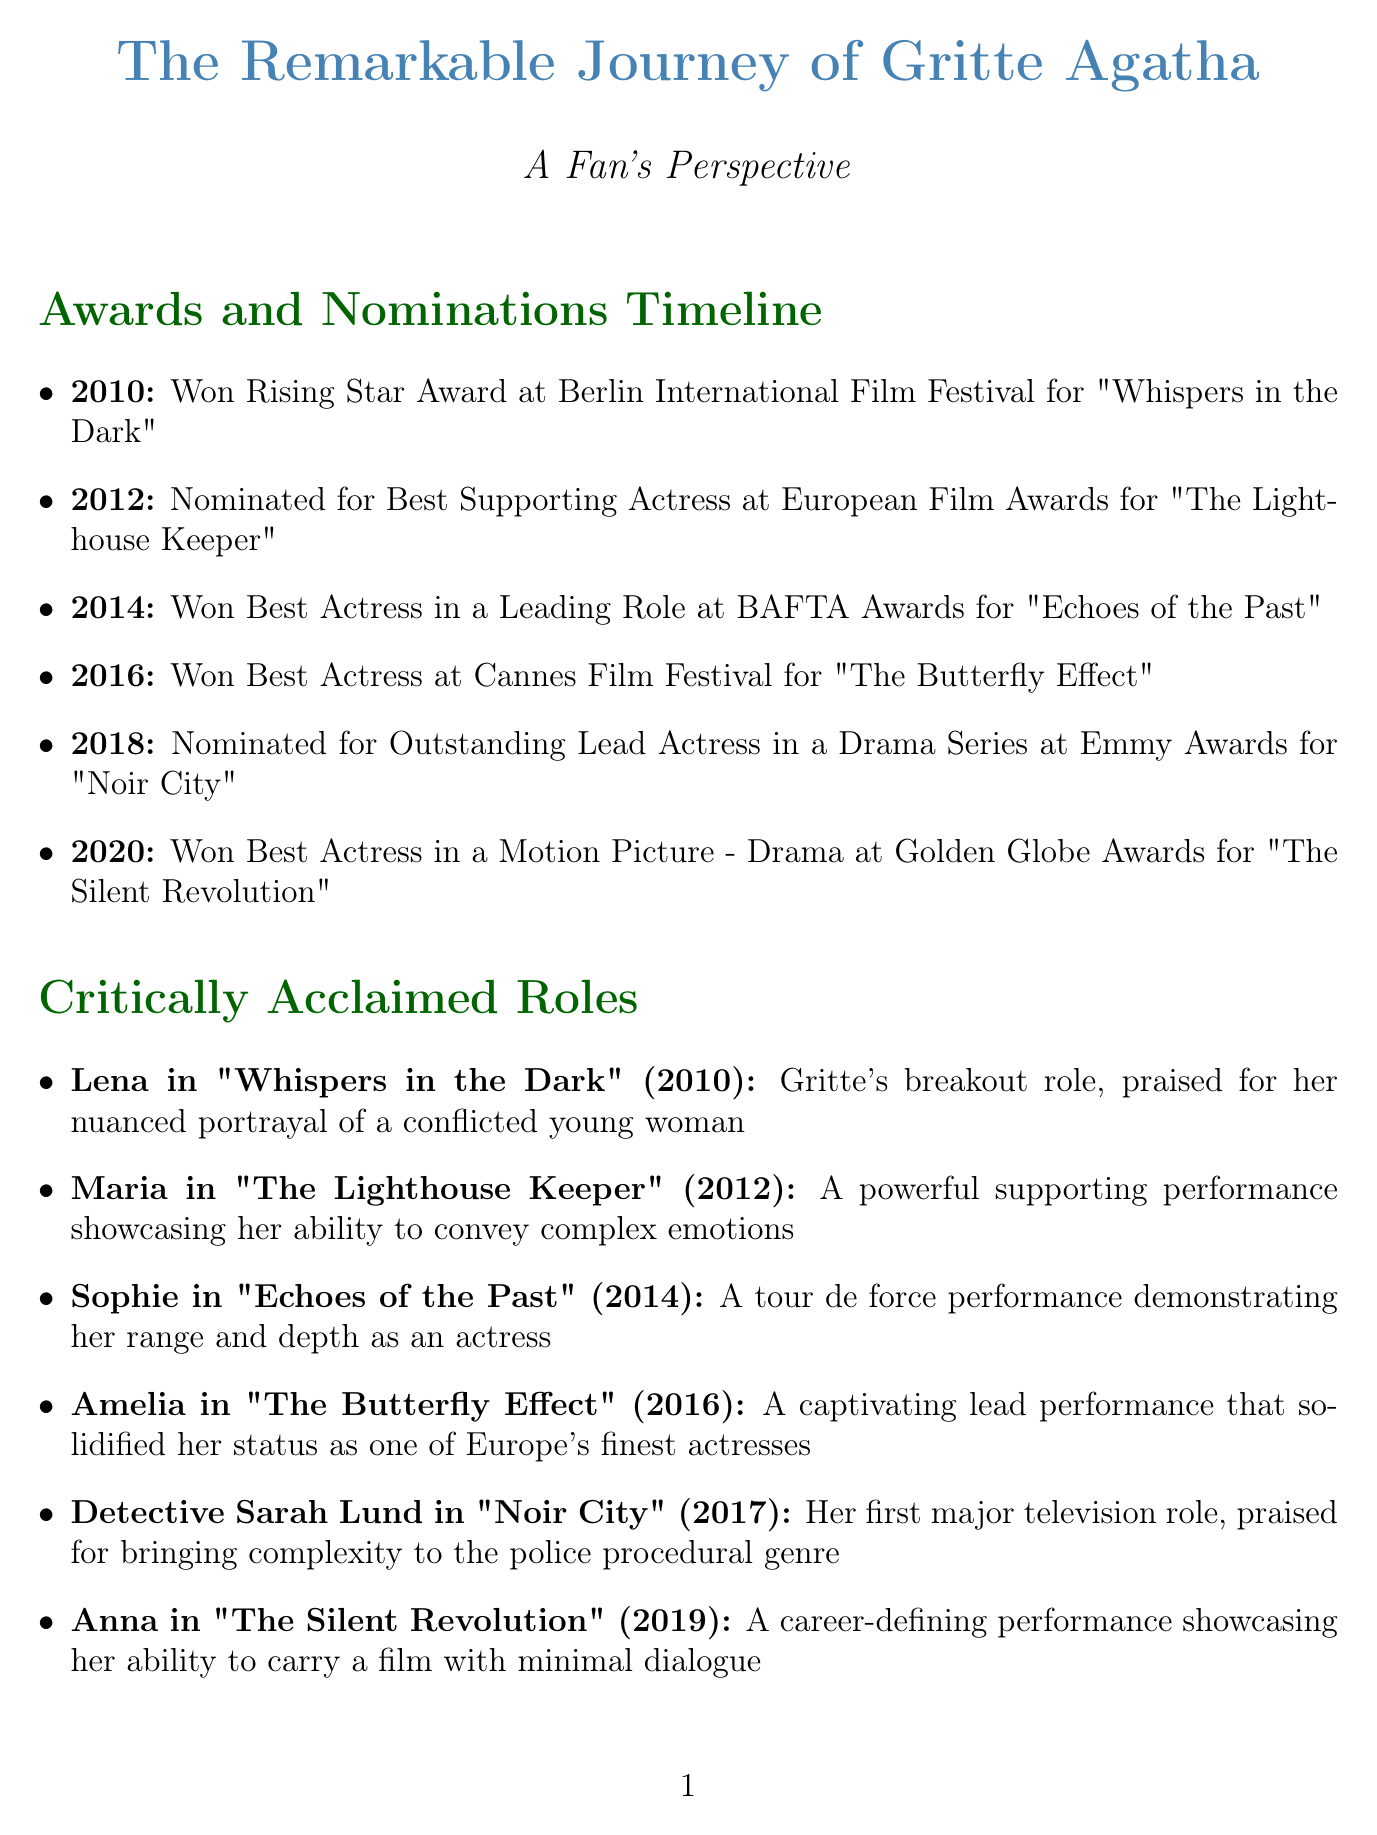What award did Gritte Agatha win in 2010? Gritte Agatha won the Rising Star Award at the Berlin International Film Festival for her role in "Whispers in the Dark."
Answer: Rising Star Award Which role earned Gritte Agatha a BAFTA Award in 2014? The BAFTA Award in 2014 was won for her role as Sophie in the film "Echoes of the Past."
Answer: Sophie in "Echoes of the Past" How many awards did Gritte Agatha win between 2010 and 2020? Gritte Agatha won 4 awards during this time: Rising Star Award, Best Actress in a Leading Role, Best Actress at Cannes, and Best Actress in a Motion Picture - Drama.
Answer: 4 What significant event took place for Gritte Agatha in 2011? In 2011, Gritte Agatha was named 'Shooting Star' at the Berlin International Film Festival.
Answer: Named 'Shooting Star' Which character did Gritte portray in the film "The Silent Revolution"? She portrayed the character Anna in "The Silent Revolution," which was a career-defining performance.
Answer: Anna What major organization did Gritte Agatha become associated with in 2017? Gritte Agatha was appointed as a UNICEF Goodwill Ambassador in 2017.
Answer: UNICEF Which quote reflects Gritte Agatha's commitment to challenging roles? The quote that reflects this is, "I'm drawn to roles that challenge me and push me out of my comfort zone."
Answer: "I'm drawn to roles that challenge me and push me out of my comfort zone." In what year did Gritte launch her own production company? Gritte launched her production company, 'Agatha Films,' in 2019.
Answer: 2019 What is one of the reasons fans admire Gritte Agatha? Fans admire her for her seamless transition between film and television roles.
Answer: Seamless transition between film and television roles 